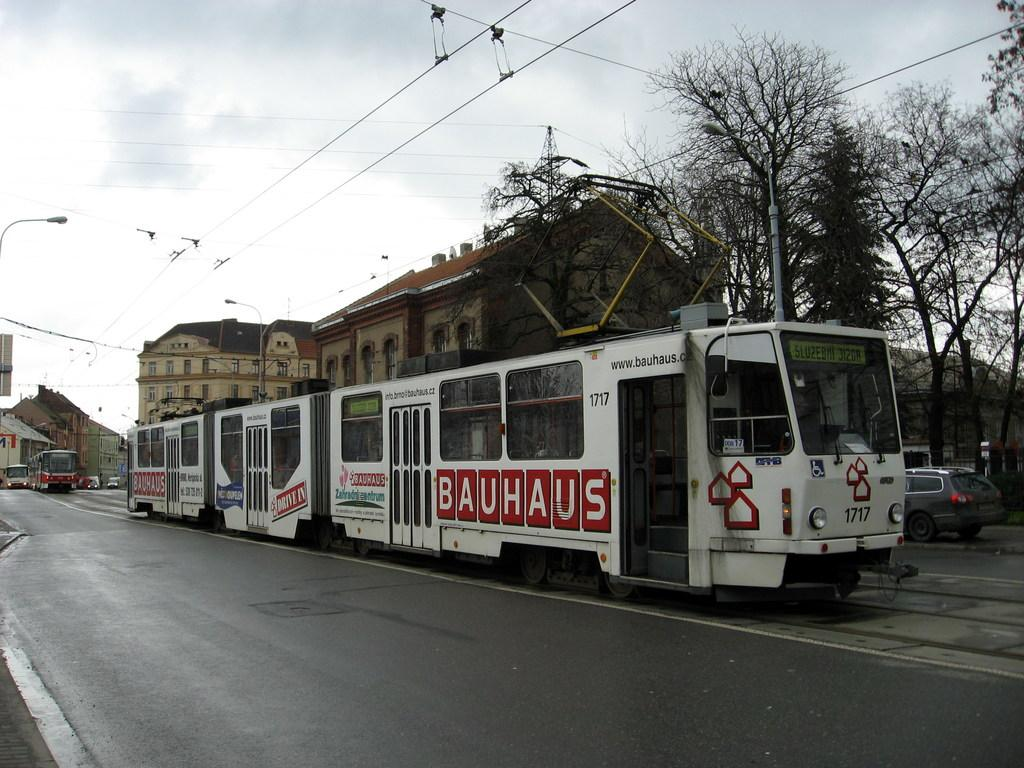What type of structures can be seen in the image? There are buildings in the image. What feature do the buildings have? The buildings have windows. What else can be seen on the ground in the image? There are vehicles on the road in the image. What type of natural elements are present in the image? Trees are present in the image. What infrastructure elements can be seen in the image? Electric poles and electric wires are visible in the image. What part of the natural environment is visible in the image? The sky is visible in the image. How far away is the spot where the buildings are located in the image? The question about distance is not relevant to the image, as it does not provide any information about the distance between the viewer and the buildings. Are the buildings in the image sleeping? The concept of buildings sleeping is not applicable, as buildings are inanimate objects and do not have the ability to sleep. 